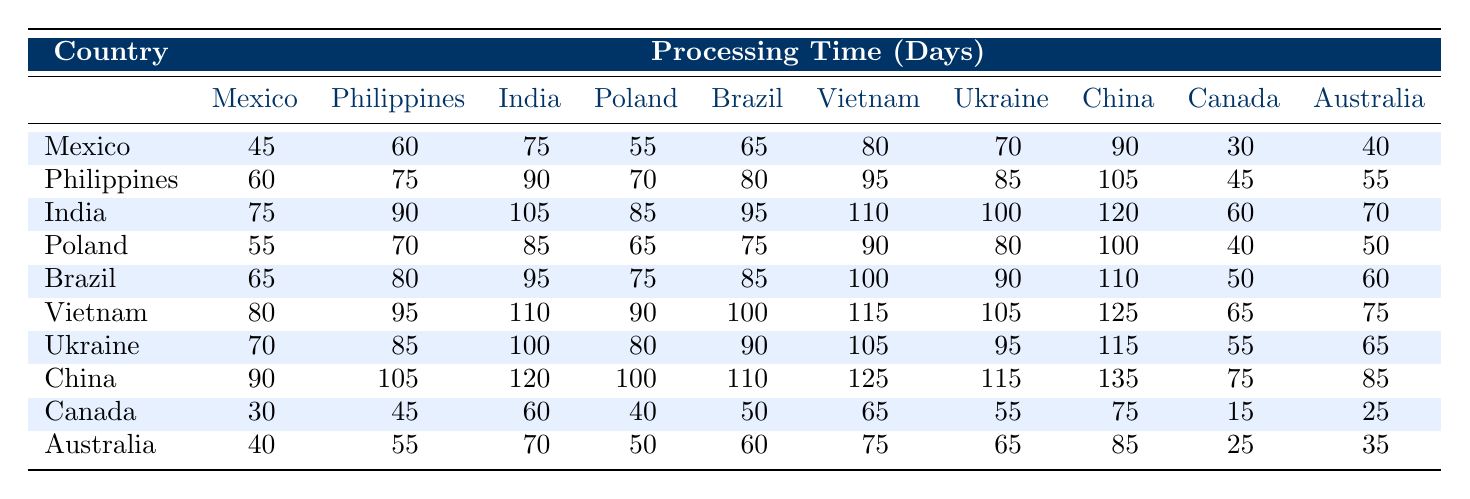What is the processing time for a visa application from Canada? In the table, we can find the row corresponding to Canada. The processing times listed for Canada are 30, 45, 60, 40, 50, 65, 55, 75, 15, and 25 days.
Answer: The processing time is 30, 45, 60, 40, 50, 65, 55, 75, 15, and 25 days Which country has the longest processing time? To find the longest processing time, we need to look for the maximum value in the entire table. Scanning through the table, the maximum value is 135 days for China.
Answer: China has the longest processing time of 135 days What is the average processing time for visa applications from India? The processing times for India are 75, 90, 105, 85, 95, 110, 100, 120, 60, and 70 days. Summing these values gives (75 + 90 + 105 + 85 + 95 + 110 + 100 + 120 + 60 + 70) = 1,030 days. Dividing by 10 gives an average of 103 days.
Answer: The average processing time for India is 103 days Is the processing time for carpenters from Mexico always shorter than for those from Poland? We can compare the processing times directly for each entry in the table. In total, Mexico has processing times of 45, 60, 75, 55, 65, 80, 70, 90, 30, and 40 days, while Poland has 55, 70, 85, 65, 75, 90, 80, 100, 40, and 50 days. Looking through both lists, Mexico's times are not always shorter; for example, the time of 55 days from Poland is less than the 60 from Mexico.
Answer: No, Mexico's processing time is not always shorter What is the total processing time for carpenters from Vietnam? The processing times for Vietnam are 80, 95, 110, 90, 100, 115, 105, 125, 65, and 75 days. Summing these values gives (80 + 95 + 110 + 90 + 100 + 115 + 105 + 125 + 65 + 75) = 1,100 days.
Answer: The total processing time for Vietnam is 1,100 days Which country has the second shortest processing time for carpenters? To find the second shortest processing time, we need to first find the shortest (15 days for Canada) and then look for the next lowest value in the table. The second shortest processing time is 25 days for Canada.
Answer: The second shortest processing time is 25 days for Canada How does the processing time for carpenters from Brazil compare with those from Australia? The processing times for Brazil are 65, 80, 95, 75, 85, 100, 90, 110, 50, and 60 days, while for Australia the times are 40, 55, 70, 50, 60, 75, 65, 85, 25, and 35 days. Comparing all values, Brazil generally has longer processing times, with the shortest time for Brazil being 65 days compared to 40 for Australia.
Answer: Brazil has longer processing times compared to Australia Do carpenters from the Philippines have consistently longer processing times than those from China? Checking the processing times, the Philippines has times of 60, 75, 90, 70, 80, 95, 85, 105, 45, and 55 days, while China has times of 90, 105, 120, 100, 110, 125, 115, 135, 75, and 85 days. Comparing each entry, it is clear that for the majority of entries, carpenters from the Philippines do have shorter times, but not in all cases; for example, the 60 days for Philippines is less than 90 for China.
Answer: No, they do not have consistently longer processing times 